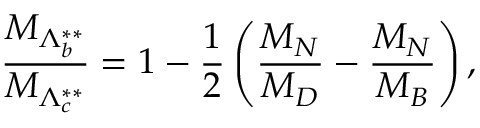<formula> <loc_0><loc_0><loc_500><loc_500>{ \frac { M _ { \Lambda _ { b } ^ { * * } } } { M _ { \Lambda _ { c } ^ { * * } } } } = 1 - { \frac { 1 } { 2 } } \left ( { \frac { M _ { N } } { M _ { D } } } - { \frac { M _ { N } } { M _ { B } } } \right ) ,</formula> 